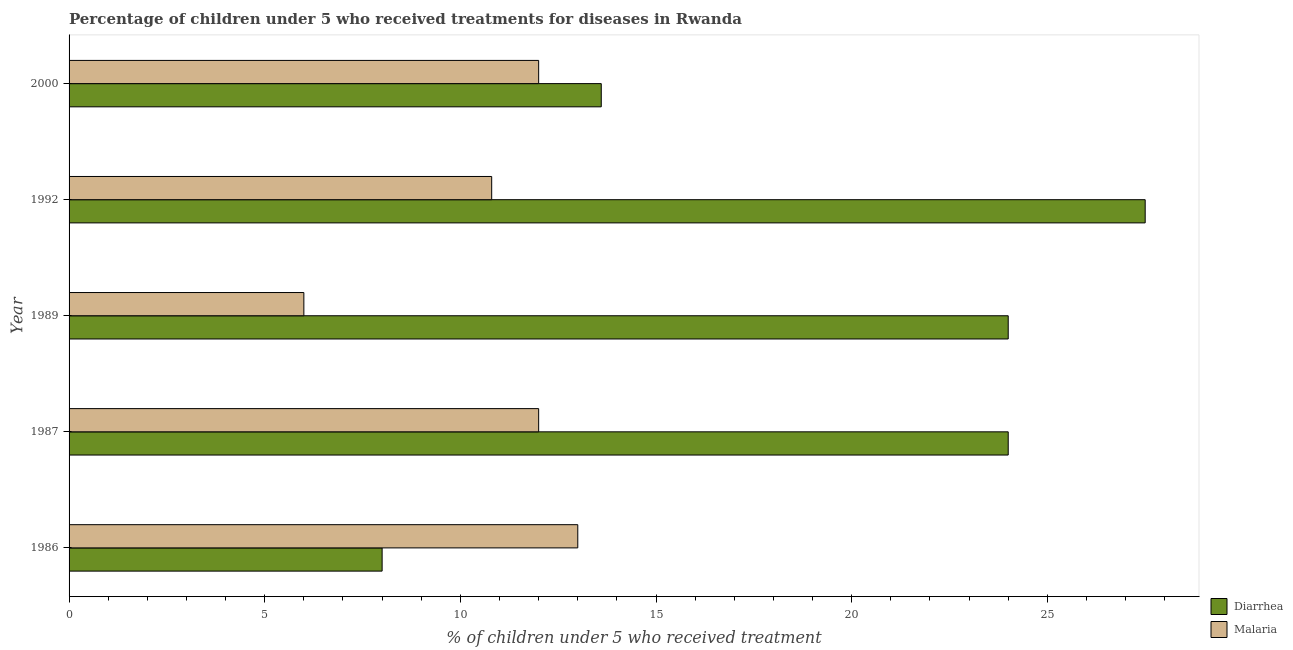How many groups of bars are there?
Make the answer very short. 5. Are the number of bars per tick equal to the number of legend labels?
Make the answer very short. Yes. Are the number of bars on each tick of the Y-axis equal?
Your response must be concise. Yes. How many bars are there on the 1st tick from the top?
Your answer should be compact. 2. What is the label of the 1st group of bars from the top?
Keep it short and to the point. 2000. In how many cases, is the number of bars for a given year not equal to the number of legend labels?
Ensure brevity in your answer.  0. Across all years, what is the minimum percentage of children who received treatment for diarrhoea?
Keep it short and to the point. 8. In which year was the percentage of children who received treatment for malaria maximum?
Make the answer very short. 1986. What is the total percentage of children who received treatment for diarrhoea in the graph?
Ensure brevity in your answer.  97.1. What is the difference between the percentage of children who received treatment for malaria in 1989 and that in 2000?
Your answer should be very brief. -6. What is the average percentage of children who received treatment for diarrhoea per year?
Offer a terse response. 19.42. What is the ratio of the percentage of children who received treatment for malaria in 1986 to that in 2000?
Provide a short and direct response. 1.08. Is the percentage of children who received treatment for diarrhoea in 1986 less than that in 1989?
Give a very brief answer. Yes. What is the difference between the highest and the second highest percentage of children who received treatment for malaria?
Keep it short and to the point. 1. In how many years, is the percentage of children who received treatment for diarrhoea greater than the average percentage of children who received treatment for diarrhoea taken over all years?
Offer a terse response. 3. What does the 2nd bar from the top in 2000 represents?
Provide a succinct answer. Diarrhea. What does the 1st bar from the bottom in 1992 represents?
Offer a terse response. Diarrhea. How many years are there in the graph?
Offer a terse response. 5. Are the values on the major ticks of X-axis written in scientific E-notation?
Offer a terse response. No. Does the graph contain grids?
Your answer should be very brief. No. Where does the legend appear in the graph?
Provide a short and direct response. Bottom right. How many legend labels are there?
Offer a terse response. 2. How are the legend labels stacked?
Keep it short and to the point. Vertical. What is the title of the graph?
Ensure brevity in your answer.  Percentage of children under 5 who received treatments for diseases in Rwanda. Does "National Tourists" appear as one of the legend labels in the graph?
Provide a succinct answer. No. What is the label or title of the X-axis?
Your response must be concise. % of children under 5 who received treatment. What is the % of children under 5 who received treatment of Diarrhea in 1986?
Provide a succinct answer. 8. What is the % of children under 5 who received treatment in Malaria in 1986?
Your answer should be very brief. 13. What is the % of children under 5 who received treatment of Diarrhea in 1989?
Give a very brief answer. 24. What is the % of children under 5 who received treatment of Diarrhea in 1992?
Offer a very short reply. 27.5. What is the % of children under 5 who received treatment in Malaria in 1992?
Keep it short and to the point. 10.8. What is the % of children under 5 who received treatment in Diarrhea in 2000?
Provide a succinct answer. 13.6. What is the % of children under 5 who received treatment in Malaria in 2000?
Your answer should be very brief. 12. Across all years, what is the maximum % of children under 5 who received treatment of Diarrhea?
Keep it short and to the point. 27.5. Across all years, what is the maximum % of children under 5 who received treatment in Malaria?
Keep it short and to the point. 13. Across all years, what is the minimum % of children under 5 who received treatment in Diarrhea?
Your answer should be very brief. 8. Across all years, what is the minimum % of children under 5 who received treatment in Malaria?
Keep it short and to the point. 6. What is the total % of children under 5 who received treatment in Diarrhea in the graph?
Ensure brevity in your answer.  97.1. What is the total % of children under 5 who received treatment of Malaria in the graph?
Your answer should be compact. 53.8. What is the difference between the % of children under 5 who received treatment in Diarrhea in 1986 and that in 1987?
Ensure brevity in your answer.  -16. What is the difference between the % of children under 5 who received treatment of Diarrhea in 1986 and that in 1989?
Ensure brevity in your answer.  -16. What is the difference between the % of children under 5 who received treatment of Malaria in 1986 and that in 1989?
Offer a terse response. 7. What is the difference between the % of children under 5 who received treatment of Diarrhea in 1986 and that in 1992?
Provide a short and direct response. -19.5. What is the difference between the % of children under 5 who received treatment of Malaria in 1986 and that in 2000?
Offer a very short reply. 1. What is the difference between the % of children under 5 who received treatment of Malaria in 1987 and that in 1989?
Keep it short and to the point. 6. What is the difference between the % of children under 5 who received treatment in Malaria in 1987 and that in 1992?
Offer a terse response. 1.2. What is the difference between the % of children under 5 who received treatment of Diarrhea in 1989 and that in 1992?
Make the answer very short. -3.5. What is the difference between the % of children under 5 who received treatment of Malaria in 1989 and that in 1992?
Make the answer very short. -4.8. What is the difference between the % of children under 5 who received treatment of Malaria in 1989 and that in 2000?
Your answer should be very brief. -6. What is the difference between the % of children under 5 who received treatment in Malaria in 1992 and that in 2000?
Your answer should be compact. -1.2. What is the difference between the % of children under 5 who received treatment in Diarrhea in 1986 and the % of children under 5 who received treatment in Malaria in 1989?
Your response must be concise. 2. What is the difference between the % of children under 5 who received treatment in Diarrhea in 1986 and the % of children under 5 who received treatment in Malaria in 1992?
Provide a short and direct response. -2.8. What is the difference between the % of children under 5 who received treatment of Diarrhea in 1986 and the % of children under 5 who received treatment of Malaria in 2000?
Offer a very short reply. -4. What is the difference between the % of children under 5 who received treatment of Diarrhea in 1987 and the % of children under 5 who received treatment of Malaria in 1989?
Make the answer very short. 18. What is the average % of children under 5 who received treatment in Diarrhea per year?
Your answer should be compact. 19.42. What is the average % of children under 5 who received treatment of Malaria per year?
Your answer should be compact. 10.76. In the year 1987, what is the difference between the % of children under 5 who received treatment of Diarrhea and % of children under 5 who received treatment of Malaria?
Make the answer very short. 12. In the year 2000, what is the difference between the % of children under 5 who received treatment in Diarrhea and % of children under 5 who received treatment in Malaria?
Offer a terse response. 1.6. What is the ratio of the % of children under 5 who received treatment in Malaria in 1986 to that in 1987?
Make the answer very short. 1.08. What is the ratio of the % of children under 5 who received treatment of Diarrhea in 1986 to that in 1989?
Your answer should be compact. 0.33. What is the ratio of the % of children under 5 who received treatment of Malaria in 1986 to that in 1989?
Offer a very short reply. 2.17. What is the ratio of the % of children under 5 who received treatment of Diarrhea in 1986 to that in 1992?
Offer a terse response. 0.29. What is the ratio of the % of children under 5 who received treatment of Malaria in 1986 to that in 1992?
Offer a very short reply. 1.2. What is the ratio of the % of children under 5 who received treatment in Diarrhea in 1986 to that in 2000?
Your response must be concise. 0.59. What is the ratio of the % of children under 5 who received treatment in Malaria in 1986 to that in 2000?
Your answer should be compact. 1.08. What is the ratio of the % of children under 5 who received treatment in Diarrhea in 1987 to that in 1992?
Provide a succinct answer. 0.87. What is the ratio of the % of children under 5 who received treatment in Diarrhea in 1987 to that in 2000?
Your answer should be very brief. 1.76. What is the ratio of the % of children under 5 who received treatment in Malaria in 1987 to that in 2000?
Provide a short and direct response. 1. What is the ratio of the % of children under 5 who received treatment in Diarrhea in 1989 to that in 1992?
Keep it short and to the point. 0.87. What is the ratio of the % of children under 5 who received treatment of Malaria in 1989 to that in 1992?
Give a very brief answer. 0.56. What is the ratio of the % of children under 5 who received treatment in Diarrhea in 1989 to that in 2000?
Your response must be concise. 1.76. What is the ratio of the % of children under 5 who received treatment in Diarrhea in 1992 to that in 2000?
Offer a very short reply. 2.02. What is the ratio of the % of children under 5 who received treatment in Malaria in 1992 to that in 2000?
Provide a succinct answer. 0.9. What is the difference between the highest and the second highest % of children under 5 who received treatment in Diarrhea?
Make the answer very short. 3.5. 